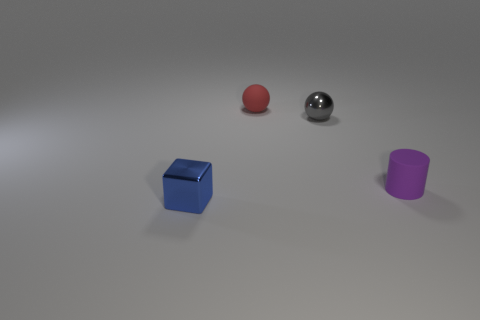How would you describe the spatial arrangement of the objects? The objects are placed with a sense of order but not in a straight line. The cube is positioned closest to us, followed by the red ball, the metallic ball, and finally, the purple cylinder. There is a sense of depth created by the relative sizes of the objects and their shadows, aligned in a way that provides a visually balanced composition. 